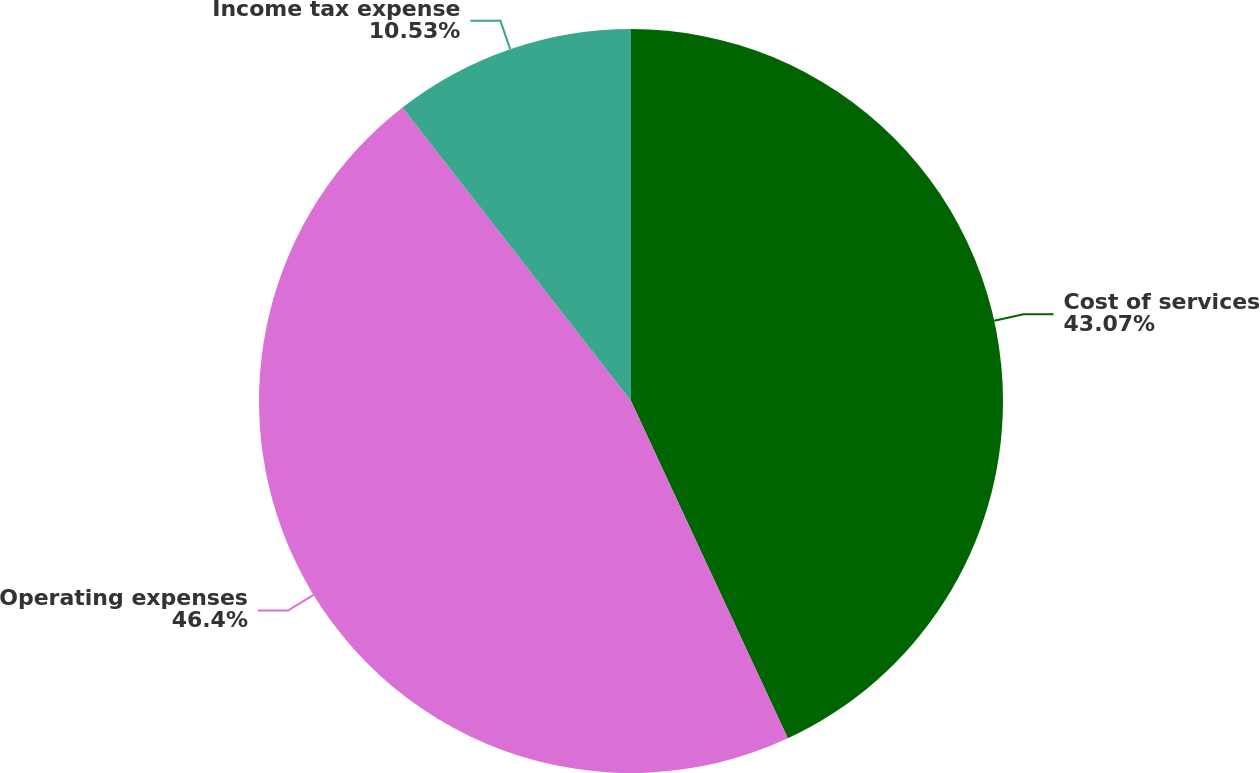<chart> <loc_0><loc_0><loc_500><loc_500><pie_chart><fcel>Cost of services<fcel>Operating expenses<fcel>Income tax expense<nl><fcel>43.07%<fcel>46.39%<fcel>10.53%<nl></chart> 